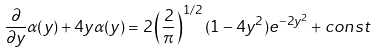Convert formula to latex. <formula><loc_0><loc_0><loc_500><loc_500>\frac { \partial } { \partial y } \alpha ( y ) + 4 y \alpha ( y ) = 2 \left ( \frac { 2 } { \pi } \right ) ^ { 1 / 2 } ( 1 - 4 y ^ { 2 } ) e ^ { - 2 y ^ { 2 } } + c o n s t</formula> 